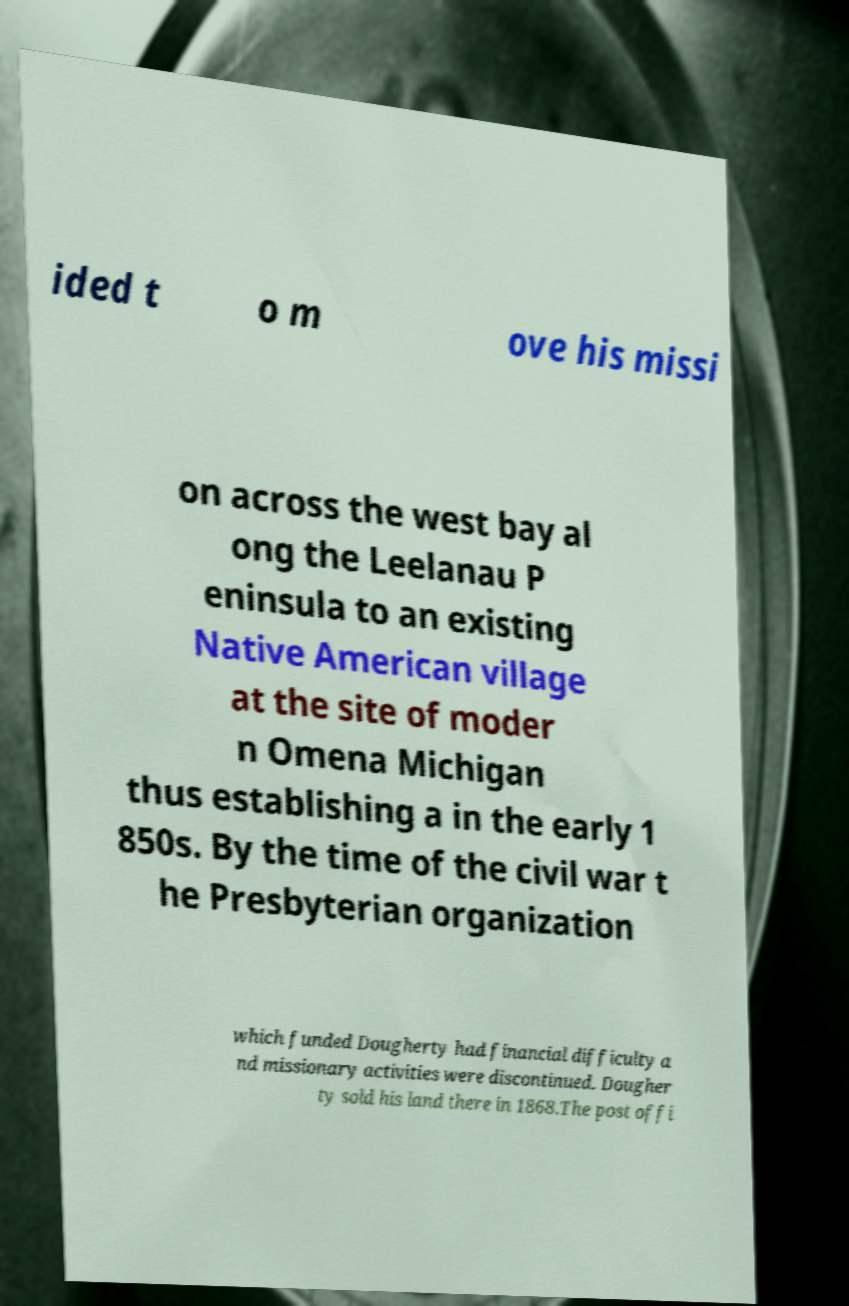Please read and relay the text visible in this image. What does it say? ided t o m ove his missi on across the west bay al ong the Leelanau P eninsula to an existing Native American village at the site of moder n Omena Michigan thus establishing a in the early 1 850s. By the time of the civil war t he Presbyterian organization which funded Dougherty had financial difficulty a nd missionary activities were discontinued. Dougher ty sold his land there in 1868.The post offi 